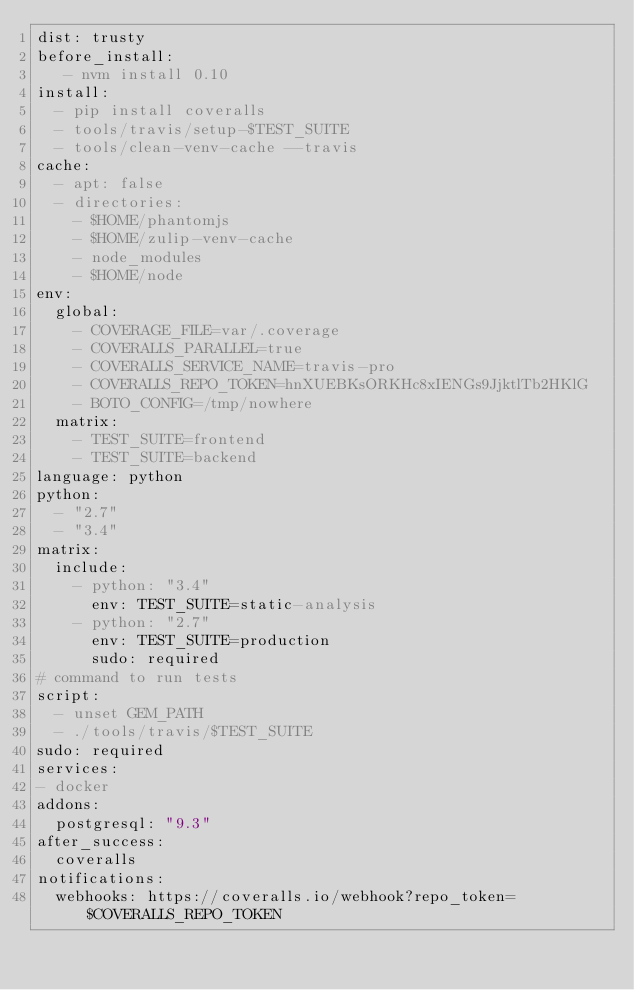Convert code to text. <code><loc_0><loc_0><loc_500><loc_500><_YAML_>dist: trusty
before_install:
   - nvm install 0.10
install:
  - pip install coveralls
  - tools/travis/setup-$TEST_SUITE
  - tools/clean-venv-cache --travis
cache:
  - apt: false
  - directories:
    - $HOME/phantomjs
    - $HOME/zulip-venv-cache
    - node_modules
    - $HOME/node
env:
  global:
    - COVERAGE_FILE=var/.coverage
    - COVERALLS_PARALLEL=true
    - COVERALLS_SERVICE_NAME=travis-pro
    - COVERALLS_REPO_TOKEN=hnXUEBKsORKHc8xIENGs9JjktlTb2HKlG
    - BOTO_CONFIG=/tmp/nowhere
  matrix:
    - TEST_SUITE=frontend
    - TEST_SUITE=backend
language: python
python:
  - "2.7"
  - "3.4"
matrix:
  include:
    - python: "3.4"
      env: TEST_SUITE=static-analysis
    - python: "2.7"
      env: TEST_SUITE=production
      sudo: required
# command to run tests
script:
  - unset GEM_PATH
  - ./tools/travis/$TEST_SUITE
sudo: required
services:
- docker
addons:
  postgresql: "9.3"
after_success:
  coveralls
notifications:
  webhooks: https://coveralls.io/webhook?repo_token=$COVERALLS_REPO_TOKEN
</code> 